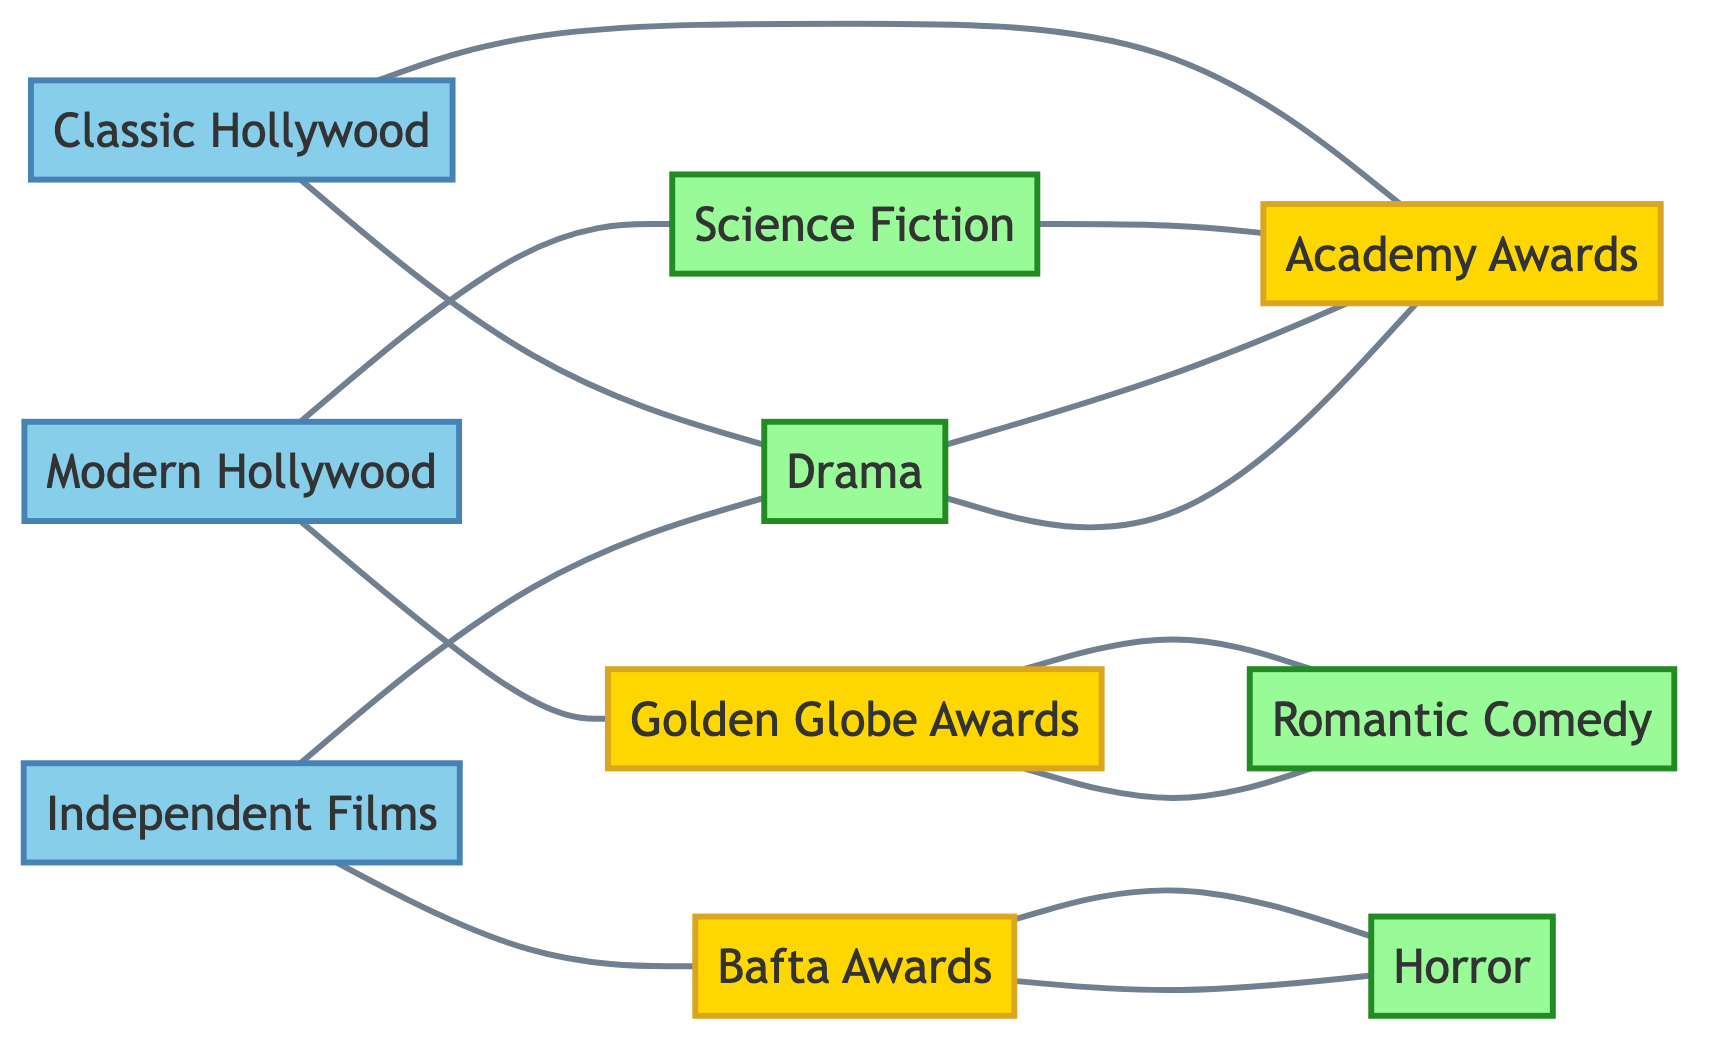What genres are connected to Classic Hollywood? The diagram shows that Classic Hollywood is connected to Drama through an edge. Therefore, the only genre associated with Classic Hollywood is Drama.
Answer: Drama How many movie eras are represented in the diagram? The diagram includes three distinct movie eras: Classic Hollywood, Modern Hollywood, and Independent Films. Counting these, the total is three.
Answer: 3 Which awards are connected to Independent Films? In the diagram, Independent Films is connected to Drama and Bafta Awards. This indicates that both Drama and the Bafta Awards are associated with Independent Films.
Answer: Drama, Bafta Awards What is the relationship between Science Fiction and Academy Awards? There is a direct edge from Science Fiction to Academy Awards in the diagram, indicating that Science Fiction films have a connection to the Academy Awards.
Answer: Connected Which genre has the most connections in the diagram? By examining the edges, Drama has connections to Classic Hollywood, Independent Films, Academy Awards, and Science Fiction. This totals four connections, more than any other genre.
Answer: Drama How many total edges are present in the diagram? The diagram has six explicit connections drawn, forming edges. Counting each link shows there are a total of twelve edges connecting the various nodes in the graph.
Answer: 12 Which award is specifically associated with Romantic Comedy? Looking at the connections within the diagram, Romantic Comedy has a direct link to Golden Globe Awards, indicating this specific association.
Answer: Golden Globe Awards Which film era is linked to the most genres? Modern Hollywood is linked to the Science Fiction genre exclusively. It is not connected to any other genres whereas Independent Films is tied to Drama. Therefore, Classic Hollywood and Independent Films demonstrate more connections.
Answer: Classic Hollywood Is Horror connected directly to any film era? The diagram shows there are edges linking genres and awards, but Horror specifically is not directly connected to any film era. It is solely connected to the Bafta Awards.
Answer: No 